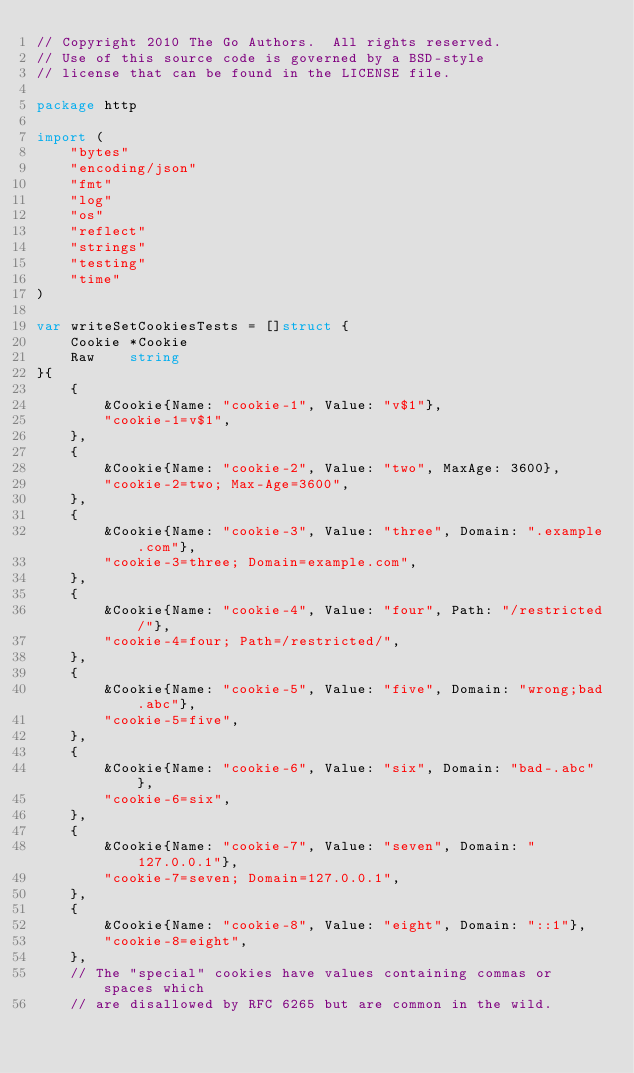Convert code to text. <code><loc_0><loc_0><loc_500><loc_500><_Go_>// Copyright 2010 The Go Authors.  All rights reserved.
// Use of this source code is governed by a BSD-style
// license that can be found in the LICENSE file.

package http

import (
	"bytes"
	"encoding/json"
	"fmt"
	"log"
	"os"
	"reflect"
	"strings"
	"testing"
	"time"
)

var writeSetCookiesTests = []struct {
	Cookie *Cookie
	Raw    string
}{
	{
		&Cookie{Name: "cookie-1", Value: "v$1"},
		"cookie-1=v$1",
	},
	{
		&Cookie{Name: "cookie-2", Value: "two", MaxAge: 3600},
		"cookie-2=two; Max-Age=3600",
	},
	{
		&Cookie{Name: "cookie-3", Value: "three", Domain: ".example.com"},
		"cookie-3=three; Domain=example.com",
	},
	{
		&Cookie{Name: "cookie-4", Value: "four", Path: "/restricted/"},
		"cookie-4=four; Path=/restricted/",
	},
	{
		&Cookie{Name: "cookie-5", Value: "five", Domain: "wrong;bad.abc"},
		"cookie-5=five",
	},
	{
		&Cookie{Name: "cookie-6", Value: "six", Domain: "bad-.abc"},
		"cookie-6=six",
	},
	{
		&Cookie{Name: "cookie-7", Value: "seven", Domain: "127.0.0.1"},
		"cookie-7=seven; Domain=127.0.0.1",
	},
	{
		&Cookie{Name: "cookie-8", Value: "eight", Domain: "::1"},
		"cookie-8=eight",
	},
	// The "special" cookies have values containing commas or spaces which
	// are disallowed by RFC 6265 but are common in the wild.</code> 